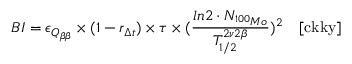<formula> <loc_0><loc_0><loc_500><loc_500>B I = \epsilon _ { Q _ { \beta \beta } } \times ( 1 - r _ { \Delta t } ) \times \tau \times ( \frac { \ln 2 \cdot N _ { ^ { 1 0 0 } M o } } { T _ { 1 / 2 } ^ { 2 \nu 2 \beta } } ) ^ { 2 } \quad [ c k k y ]</formula> 